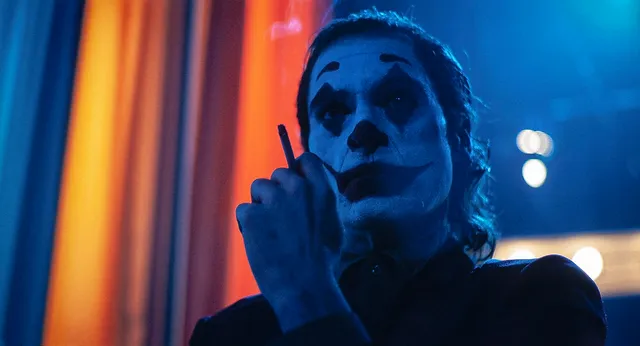What might have inspired the choice of colors in this scene? The choice of colors, specifically the juxtaposition of blue and orange, creates a striking visual dichotomy that enhances the scene's dramatic intensity. Blue typically symbolizes calm, introspection, and melancholy, while orange often represents energy, enthusiasm, and chaos. This contrast likely reflects the Joker’s complex personality – a blend of calculated calmness and unpredictable, chaotic energy. The use of such vivid and contrasting colors can draw the viewer into the psychological depth of the character and the scene, emphasizing the emotional and narrative tension. If this image were the cover of a novel, what would be the title and the tagline? Title: "The Harlequin’s Shadow" 
Tagline: "In the heart of chaos, a fractured mind stirs the storm." 